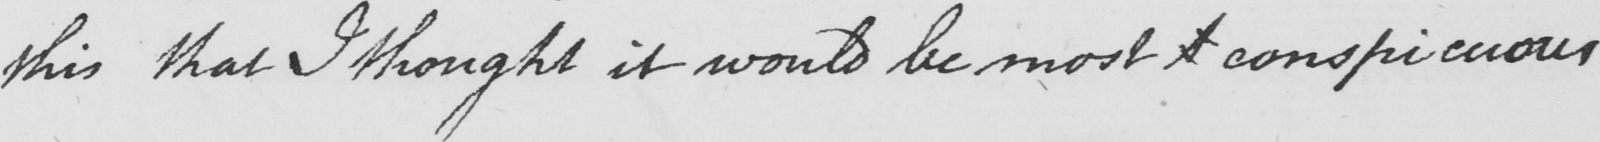Can you read and transcribe this handwriting? this that I thought it would be most  <gap/>  conspicuous 